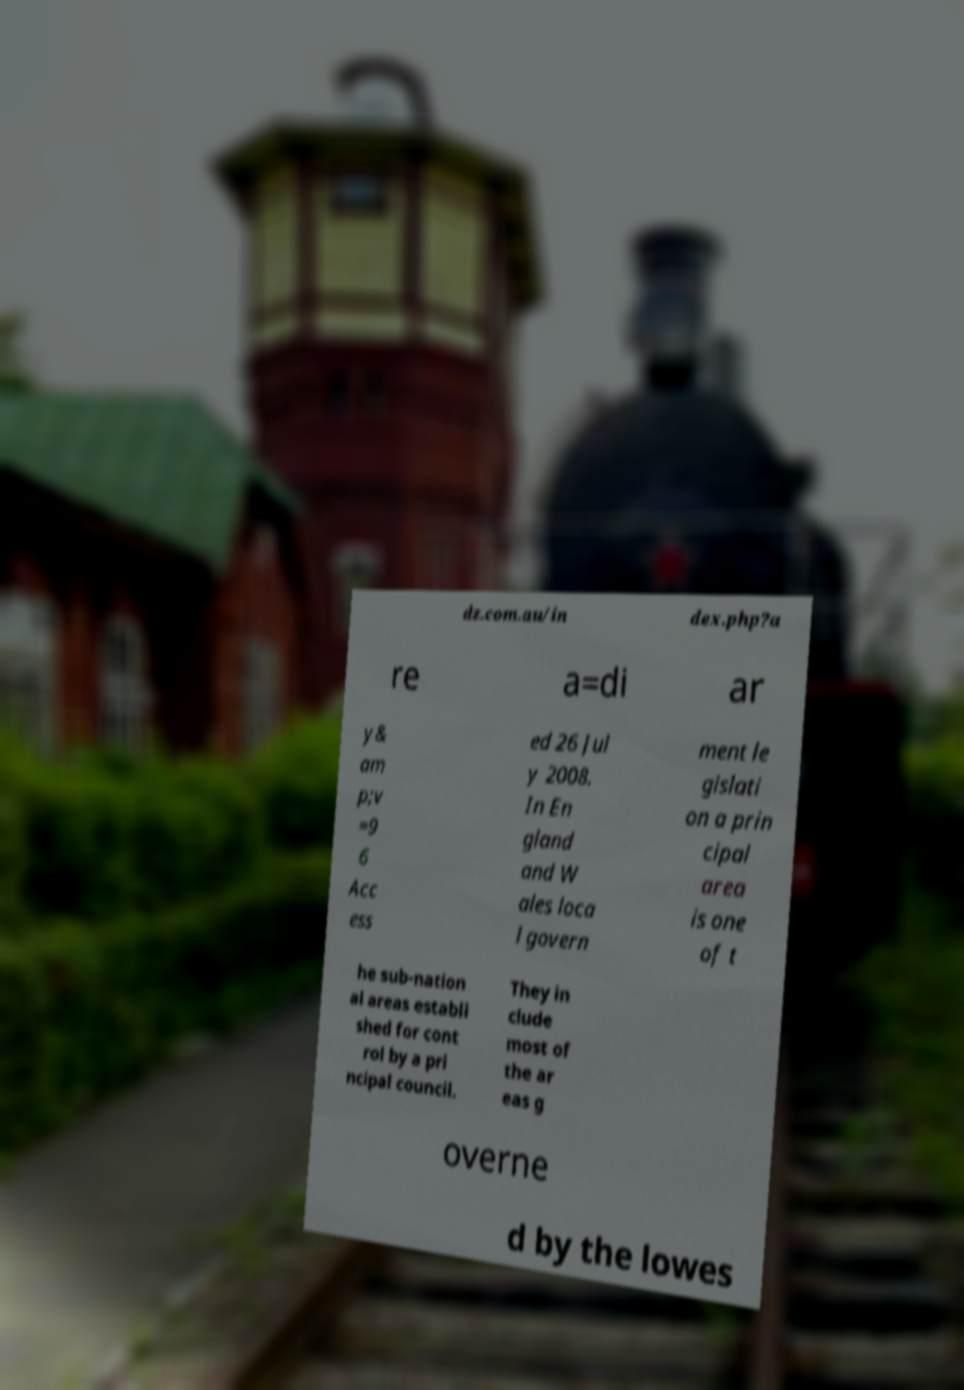I need the written content from this picture converted into text. Can you do that? dz.com.au/in dex.php?a re a=di ar y& am p;v =9 6 Acc ess ed 26 Jul y 2008. In En gland and W ales loca l govern ment le gislati on a prin cipal area is one of t he sub-nation al areas establi shed for cont rol by a pri ncipal council. They in clude most of the ar eas g overne d by the lowes 